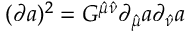Convert formula to latex. <formula><loc_0><loc_0><loc_500><loc_500>( \partial a ) ^ { 2 } = G ^ { \hat { \mu } \hat { \nu } } \partial _ { \hat { \mu } } a \partial _ { \hat { \nu } } a</formula> 